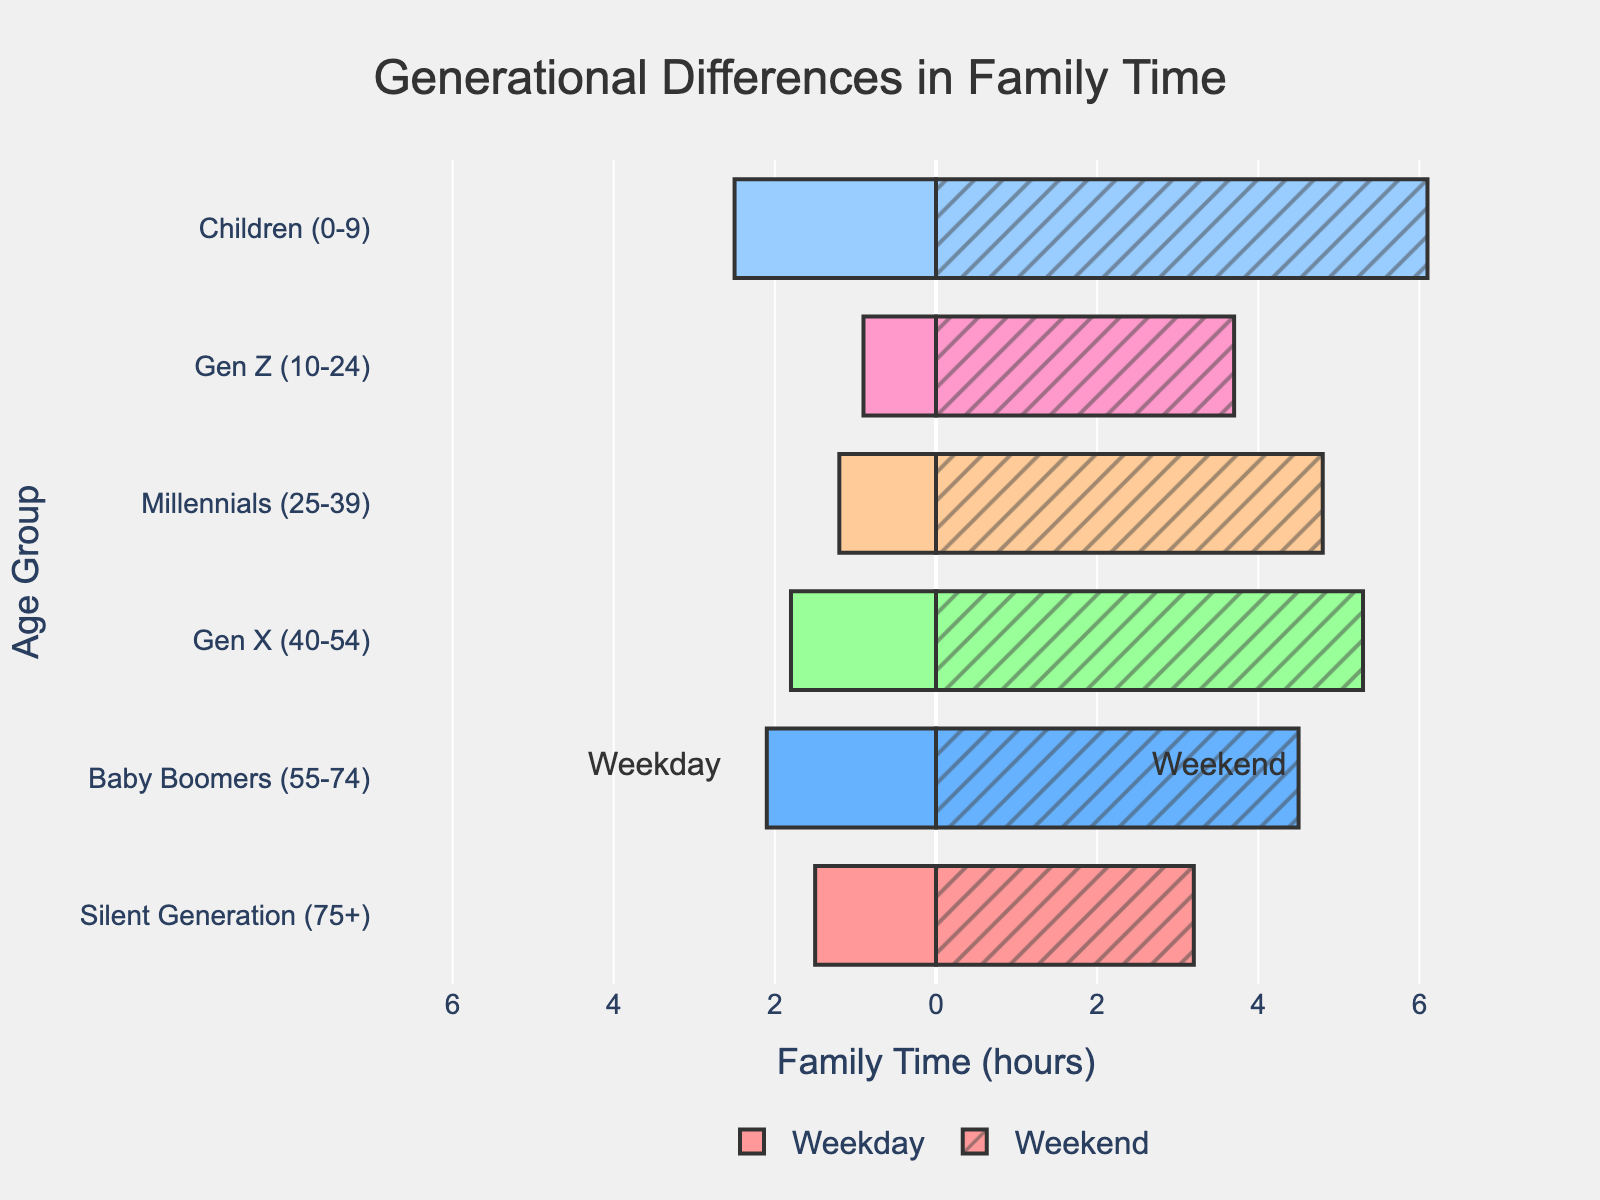Which age group spends the most family time on weekends? The figure shows weekend family time in hours for each age group. By observing the bars, it's clear that the Children (0-9) group has the longest bar on the weekend side.
Answer: Children (0-9) Which age group spends the least family time on weekdays? The figure shows weekday family time in hours for each age group. By observing the bars, the shortest bar on the weekday side belongs to Gen Z (10-24).
Answer: Gen Z (10-24) What is the total family time (weekday + weekend) spent by Baby Boomers? Baby Boomers spend 2.1 hours on weekdays and 4.5 hours on weekends. Summing these values gives 2.1 + 4.5 = 6.6 hours.
Answer: 6.6 hours Which age group has the biggest difference between weekday and weekend family time? To find the biggest difference, we need to examine the length of the bars on both sides (weekday and weekend) for each age group. The difference is largest for Children (0-9), with a difference of 6.1 - 2.5 = 3.6 hours.
Answer: Children (0-9) How does family time on weekends compare between Millennials and Gen X? By comparing the weekend bars for Millennials (4.8 hours) and Gen X (5.3 hours), we see that Gen X spends more time on weekends than Millennials.
Answer: Gen X spends more time Which age group spends more family time on weekdays: Silent Generation or Millennials? By comparing the weekday bars, the Silent Generation (1.5 hours) and Millennials (1.2 hours), the Silent Generation spends more time.
Answer: Silent Generation What is the average family time on weekends across all age groups? To find the average, sum the weekend family times for all age groups (3.2 + 4.5 + 5.3 + 4.8 + 3.7 + 6.1) = 27.6 hours, and divide by the number of groups (6). The average is 27.6 / 6 = 4.6 hours.
Answer: 4.6 hours Which group has a more evenly distributed family time between weekdays and weekends, Gen Z or Millennials? To determine even distribution, compare the differences between weekday and weekend times for both groups. Gen Z has a difference of 3.7 - 0.9 = 2.8 hours, while Millennials have a difference of 4.8 - 1.2 = 3.6 hours. Gen Z has a smaller difference and thus a more even distribution.
Answer: Gen Z 